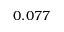<formula> <loc_0><loc_0><loc_500><loc_500>0 . 0 7 7</formula> 